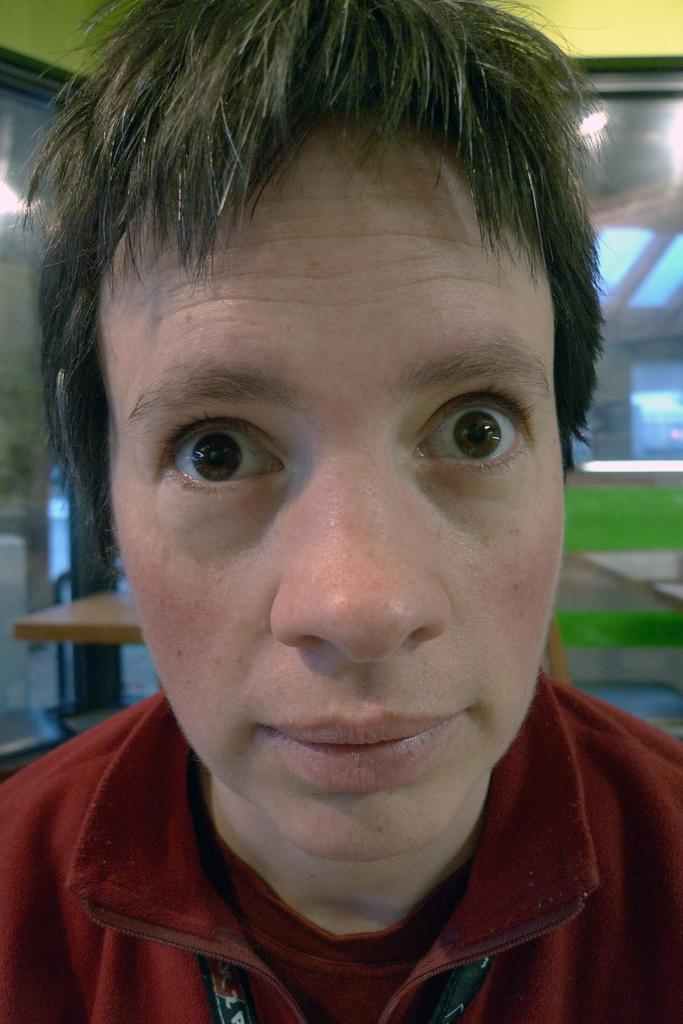Who is present in the image? There is a man in the image. What is the man wearing? The man is wearing a red shirt. What can be seen in the background of the image? There is a table, a wall, and a window in the background of the image. What loss does the stranger experience in the image? There is no stranger present in the image, and therefore no loss can be observed. 